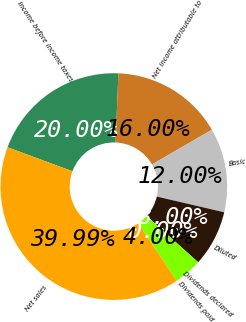<chart> <loc_0><loc_0><loc_500><loc_500><pie_chart><fcel>Income before income taxes<fcel>Net income attributable to<fcel>Basic<fcel>Diluted<fcel>Dividends declared<fcel>Dividends paid<fcel>Net sales<nl><fcel>20.0%<fcel>16.0%<fcel>12.0%<fcel>8.0%<fcel>0.0%<fcel>4.0%<fcel>39.99%<nl></chart> 